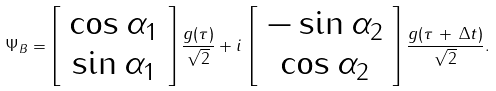<formula> <loc_0><loc_0><loc_500><loc_500>\Psi _ { B } = \left [ \begin{array} { c } \cos \alpha _ { 1 } \\ \sin \alpha _ { 1 } \end{array} \right ] \frac { g ( \tau ) } { \sqrt { 2 } } + i \, \left [ \begin{array} { c } - \sin \alpha _ { 2 } \\ \cos \alpha _ { 2 } \end{array} \right ] \frac { g ( \tau \, + \, \Delta t ) } { \sqrt { 2 } } .</formula> 